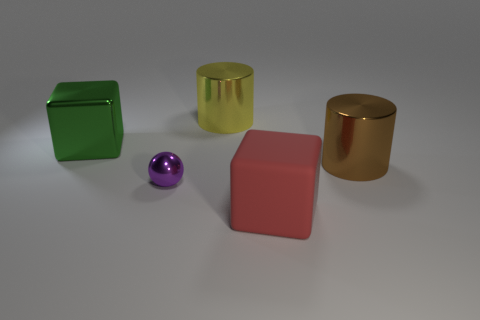Is there anything else that has the same material as the large red cube?
Offer a very short reply. No. What number of green things are big blocks or large metallic cylinders?
Your response must be concise. 1. There is a cylinder to the right of the block in front of the small purple sphere; what is its material?
Ensure brevity in your answer.  Metal. Does the large green metal object have the same shape as the purple metallic thing?
Your answer should be compact. No. There is a matte thing that is the same size as the brown metallic thing; what color is it?
Provide a succinct answer. Red. Are there any large shiny blocks of the same color as the big rubber cube?
Your response must be concise. No. Are any small gray matte blocks visible?
Your response must be concise. No. Is the big cube in front of the large green thing made of the same material as the green cube?
Your answer should be compact. No. What number of other red rubber objects have the same size as the rubber object?
Ensure brevity in your answer.  0. Are there the same number of big yellow things to the left of the green cube and big green shiny things?
Provide a succinct answer. No. 